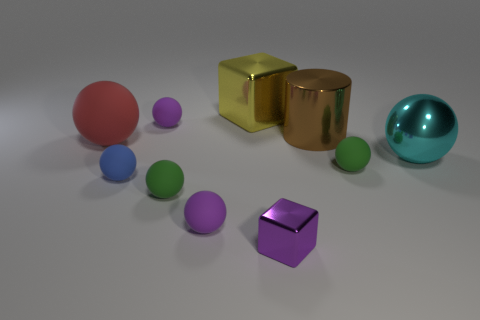Add 9 large yellow shiny objects. How many large yellow shiny objects exist? 10 Subtract all green spheres. How many spheres are left? 5 Subtract all red matte spheres. How many spheres are left? 6 Subtract 2 purple spheres. How many objects are left? 8 Subtract all blocks. How many objects are left? 8 Subtract all red blocks. Subtract all cyan cylinders. How many blocks are left? 2 Subtract all purple spheres. How many red cylinders are left? 0 Subtract all purple matte spheres. Subtract all big cyan shiny things. How many objects are left? 7 Add 5 big shiny blocks. How many big shiny blocks are left? 6 